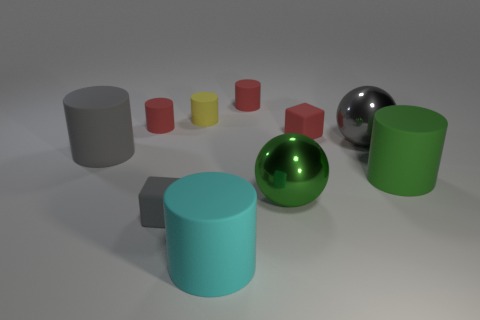What is the color of the thing in front of the tiny gray cube?
Offer a terse response. Cyan. There is a small cylinder to the right of the big cyan matte thing; is there a gray metal ball behind it?
Provide a short and direct response. No. Does the rubber cylinder that is in front of the small gray matte block have the same color as the rubber cube to the left of the green metallic thing?
Offer a very short reply. No. There is a gray shiny thing; what number of cyan rubber objects are on the right side of it?
Your answer should be compact. 0. Are the large green object on the left side of the gray ball and the small gray thing made of the same material?
Your answer should be very brief. No. How many cyan things are made of the same material as the tiny gray block?
Your response must be concise. 1. Is the number of cubes behind the green sphere greater than the number of big green matte cylinders?
Provide a short and direct response. No. Are there any other large things of the same shape as the yellow thing?
Your answer should be very brief. Yes. What number of objects are small yellow metal cubes or cyan rubber things?
Offer a terse response. 1. There is a large green thing that is left of the rubber object to the right of the red block; how many red things are behind it?
Make the answer very short. 3. 